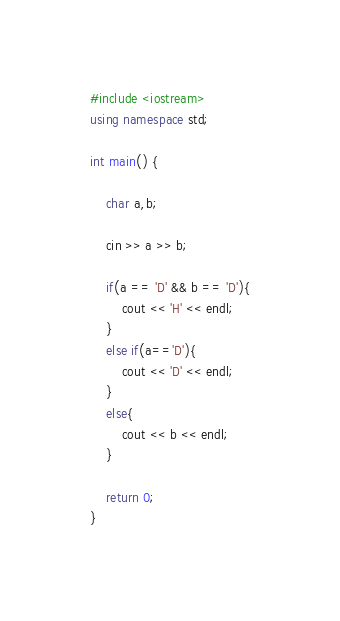<code> <loc_0><loc_0><loc_500><loc_500><_C++_>#include <iostream>
using namespace std;

int main() {

    char a,b;

    cin >> a >> b;

    if(a == 'D' && b == 'D'){
        cout << 'H' << endl;
    }
    else if(a=='D'){
        cout << 'D' << endl;
    }
    else{
        cout << b << endl;
    }

    return 0;
}</code> 